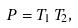<formula> <loc_0><loc_0><loc_500><loc_500>P = T _ { 1 } \, T _ { 2 } ,</formula> 